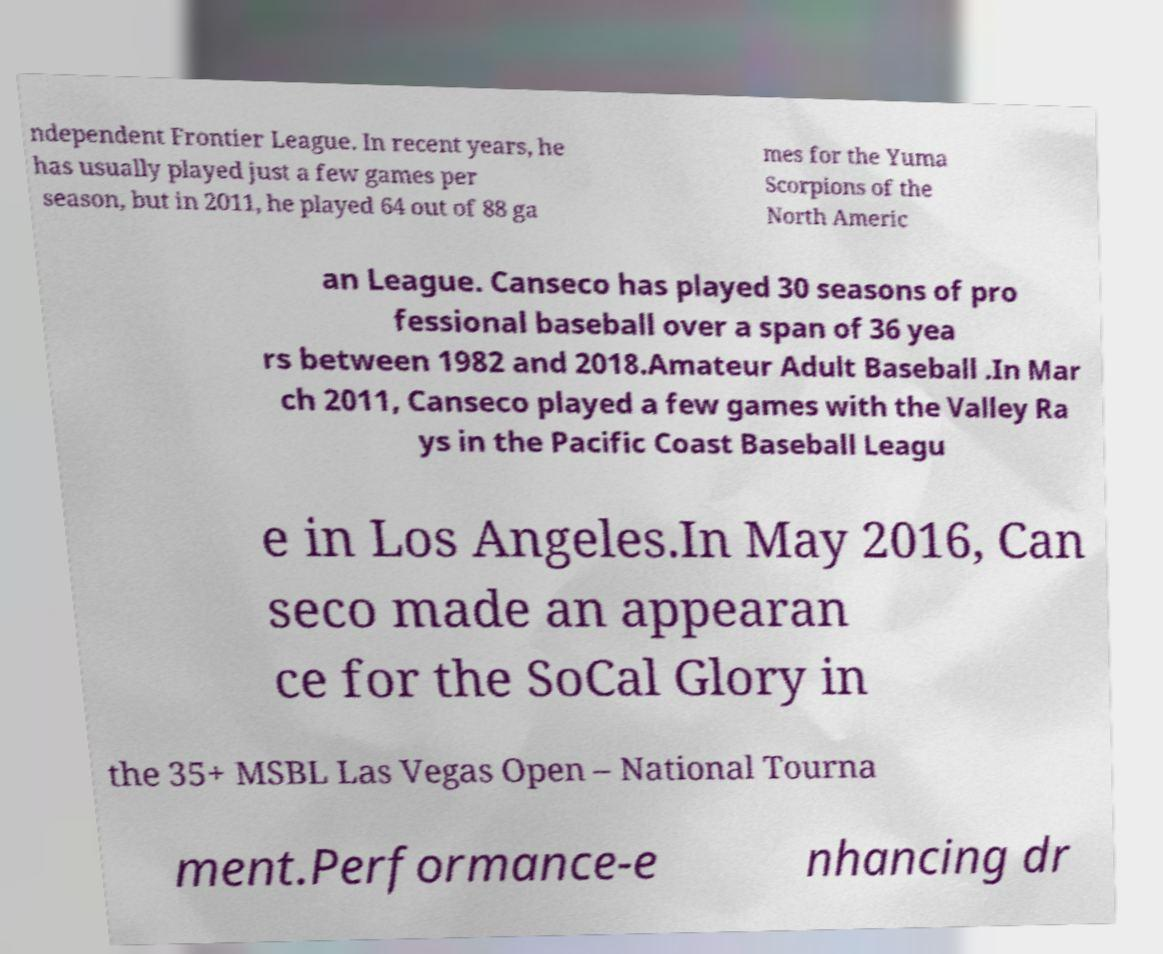There's text embedded in this image that I need extracted. Can you transcribe it verbatim? ndependent Frontier League. In recent years, he has usually played just a few games per season, but in 2011, he played 64 out of 88 ga mes for the Yuma Scorpions of the North Americ an League. Canseco has played 30 seasons of pro fessional baseball over a span of 36 yea rs between 1982 and 2018.Amateur Adult Baseball .In Mar ch 2011, Canseco played a few games with the Valley Ra ys in the Pacific Coast Baseball Leagu e in Los Angeles.In May 2016, Can seco made an appearan ce for the SoCal Glory in the 35+ MSBL Las Vegas Open – National Tourna ment.Performance-e nhancing dr 